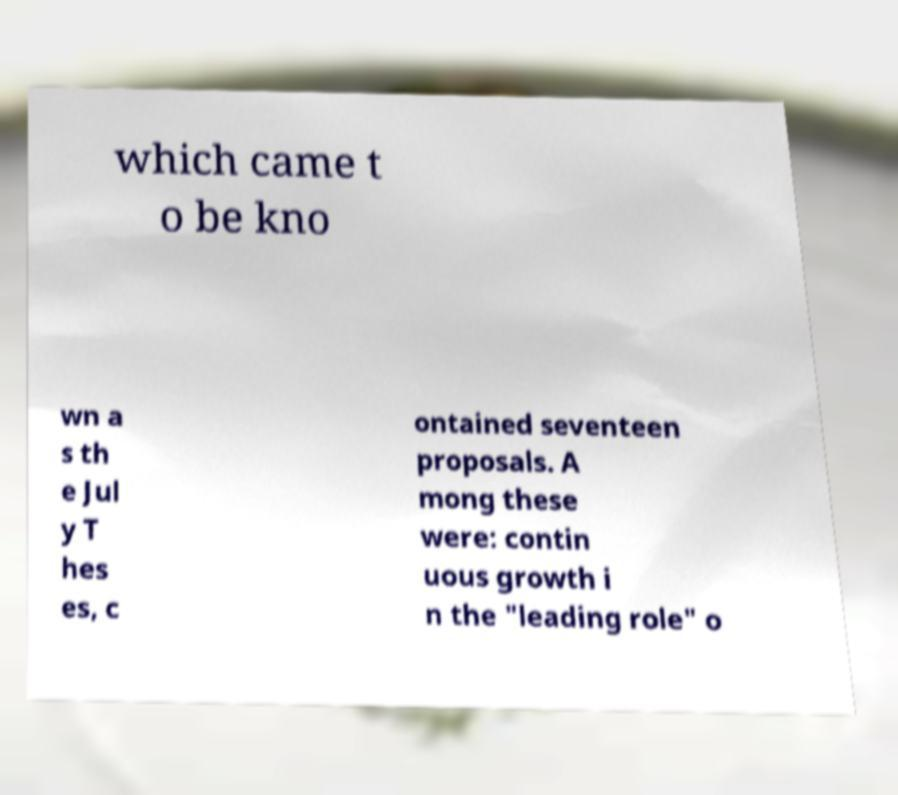What messages or text are displayed in this image? I need them in a readable, typed format. which came t o be kno wn a s th e Jul y T hes es, c ontained seventeen proposals. A mong these were: contin uous growth i n the "leading role" o 